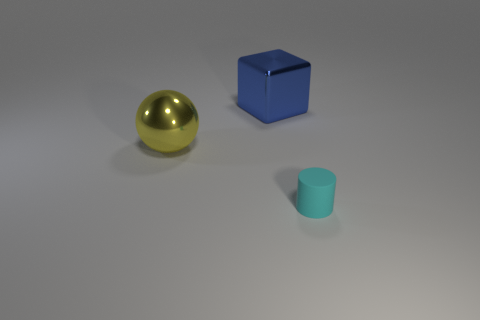Add 2 big spheres. How many objects exist? 5 Subtract all cylinders. How many objects are left? 2 Subtract 0 blue balls. How many objects are left? 3 Subtract all cyan rubber things. Subtract all tiny rubber cylinders. How many objects are left? 1 Add 1 cyan things. How many cyan things are left? 2 Add 2 tiny green balls. How many tiny green balls exist? 2 